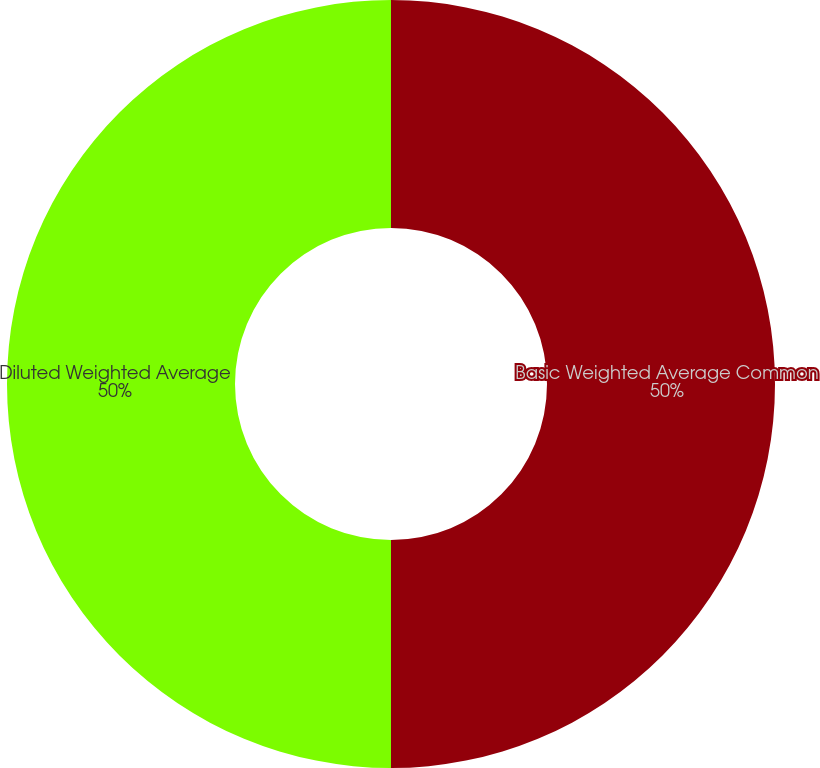<chart> <loc_0><loc_0><loc_500><loc_500><pie_chart><fcel>Basic Weighted Average Common<fcel>Diluted Weighted Average<nl><fcel>50.0%<fcel>50.0%<nl></chart> 